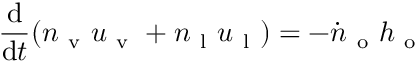<formula> <loc_0><loc_0><loc_500><loc_500>\frac { d } { d t } ( n _ { v } u _ { v } + n _ { l } u _ { l } ) = - \dot { n } _ { o } h _ { o }</formula> 